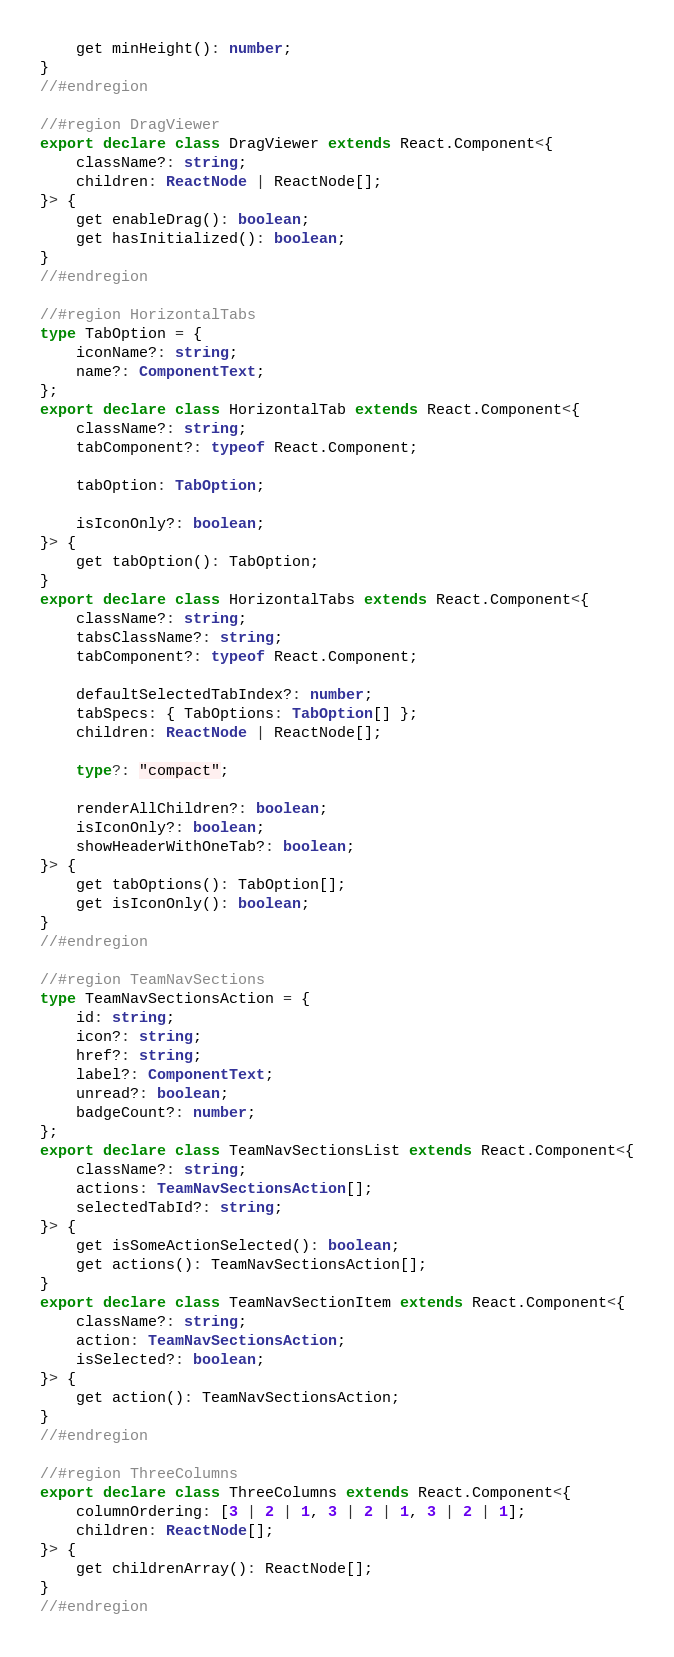Convert code to text. <code><loc_0><loc_0><loc_500><loc_500><_TypeScript_>    get minHeight(): number;
}
//#endregion

//#region DragViewer
export declare class DragViewer extends React.Component<{
    className?: string;
    children: ReactNode | ReactNode[];
}> {
    get enableDrag(): boolean;
    get hasInitialized(): boolean;
}
//#endregion

//#region HorizontalTabs
type TabOption = {
    iconName?: string;
    name?: ComponentText;
};
export declare class HorizontalTab extends React.Component<{
    className?: string;
    tabComponent?: typeof React.Component;

    tabOption: TabOption;

    isIconOnly?: boolean;
}> {
    get tabOption(): TabOption;
}
export declare class HorizontalTabs extends React.Component<{
    className?: string;
    tabsClassName?: string;
    tabComponent?: typeof React.Component;

    defaultSelectedTabIndex?: number;
    tabSpecs: { TabOptions: TabOption[] };
    children: ReactNode | ReactNode[];

    type?: "compact";

    renderAllChildren?: boolean;
    isIconOnly?: boolean;
    showHeaderWithOneTab?: boolean;
}> {
    get tabOptions(): TabOption[];
    get isIconOnly(): boolean;
}
//#endregion

//#region TeamNavSections
type TeamNavSectionsAction = {
    id: string;
    icon?: string;
    href?: string;
    label?: ComponentText;
    unread?: boolean;
    badgeCount?: number;
};
export declare class TeamNavSectionsList extends React.Component<{
    className?: string;
    actions: TeamNavSectionsAction[];
    selectedTabId?: string;
}> {
    get isSomeActionSelected(): boolean;
    get actions(): TeamNavSectionsAction[];
}
export declare class TeamNavSectionItem extends React.Component<{
    className?: string;
    action: TeamNavSectionsAction;
    isSelected?: boolean;
}> {
    get action(): TeamNavSectionsAction;
}
//#endregion

//#region ThreeColumns
export declare class ThreeColumns extends React.Component<{
    columnOrdering: [3 | 2 | 1, 3 | 2 | 1, 3 | 2 | 1];
    children: ReactNode[];
}> {
    get childrenArray(): ReactNode[];
}
//#endregion
</code> 